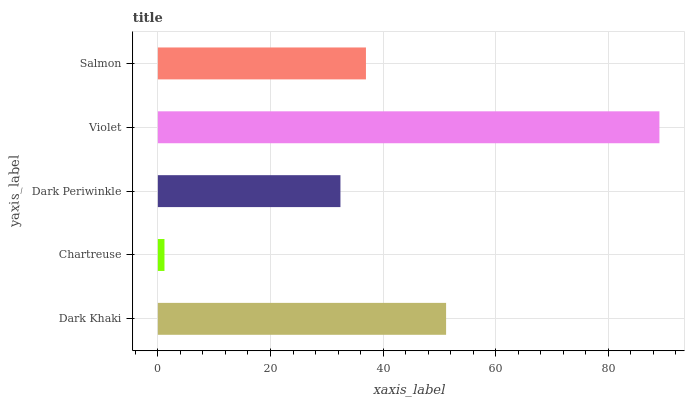Is Chartreuse the minimum?
Answer yes or no. Yes. Is Violet the maximum?
Answer yes or no. Yes. Is Dark Periwinkle the minimum?
Answer yes or no. No. Is Dark Periwinkle the maximum?
Answer yes or no. No. Is Dark Periwinkle greater than Chartreuse?
Answer yes or no. Yes. Is Chartreuse less than Dark Periwinkle?
Answer yes or no. Yes. Is Chartreuse greater than Dark Periwinkle?
Answer yes or no. No. Is Dark Periwinkle less than Chartreuse?
Answer yes or no. No. Is Salmon the high median?
Answer yes or no. Yes. Is Salmon the low median?
Answer yes or no. Yes. Is Dark Khaki the high median?
Answer yes or no. No. Is Chartreuse the low median?
Answer yes or no. No. 